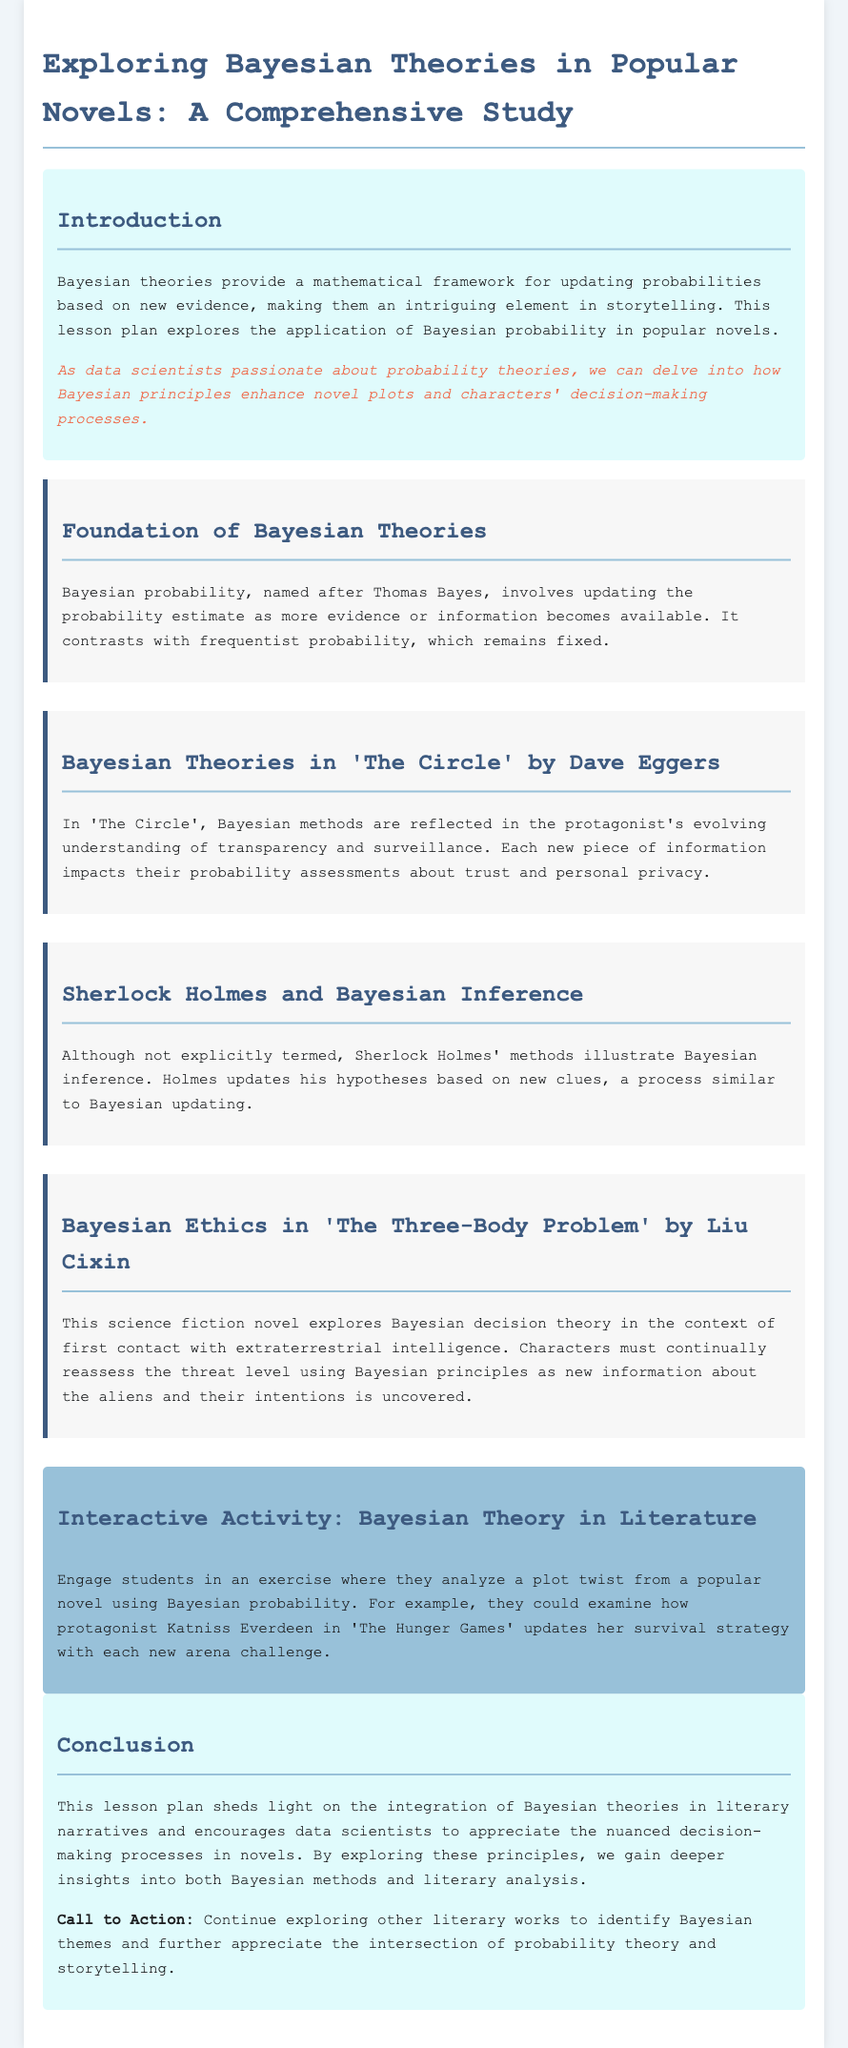what is the title of the lesson plan? The title is stated at the beginning of the document and reflects the main focus of the study.
Answer: Exploring Bayesian Theories in Popular Novels: A Comprehensive Study who is the author of 'The Circle'? The document mentions the author of 'The Circle' in its section about the novel.
Answer: Dave Eggers which character is mentioned in the interactive activity? The interactive activity suggests analyzing a plot twist involving a specific character from a novel.
Answer: Katniss Everdeen what principle is discussed in 'The Three-Body Problem'? This section specifically highlights a decision-making theory that is used in the novel.
Answer: Bayesian decision theory how does Bayesian probability differ from frequentist probability? The document states the primary distinction between the two types of probability theories.
Answer: Bayesian probability involves updating estimates 